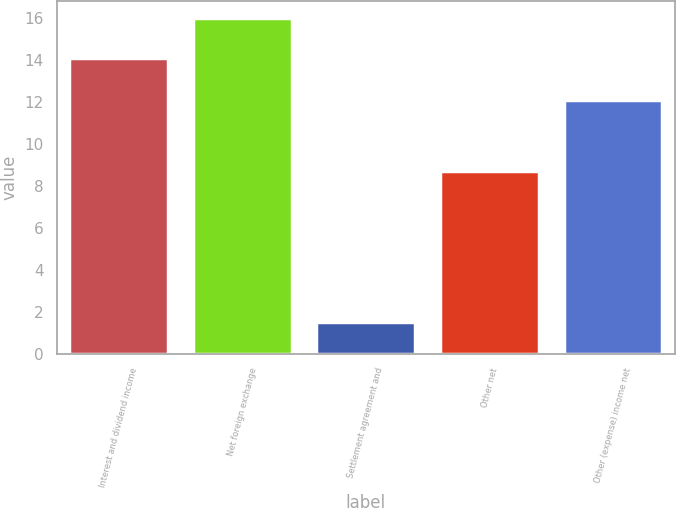Convert chart to OTSL. <chart><loc_0><loc_0><loc_500><loc_500><bar_chart><fcel>Interest and dividend income<fcel>Net foreign exchange<fcel>Settlement agreement and<fcel>Other net<fcel>Other (expense) income net<nl><fcel>14.1<fcel>16<fcel>1.5<fcel>8.7<fcel>12.1<nl></chart> 